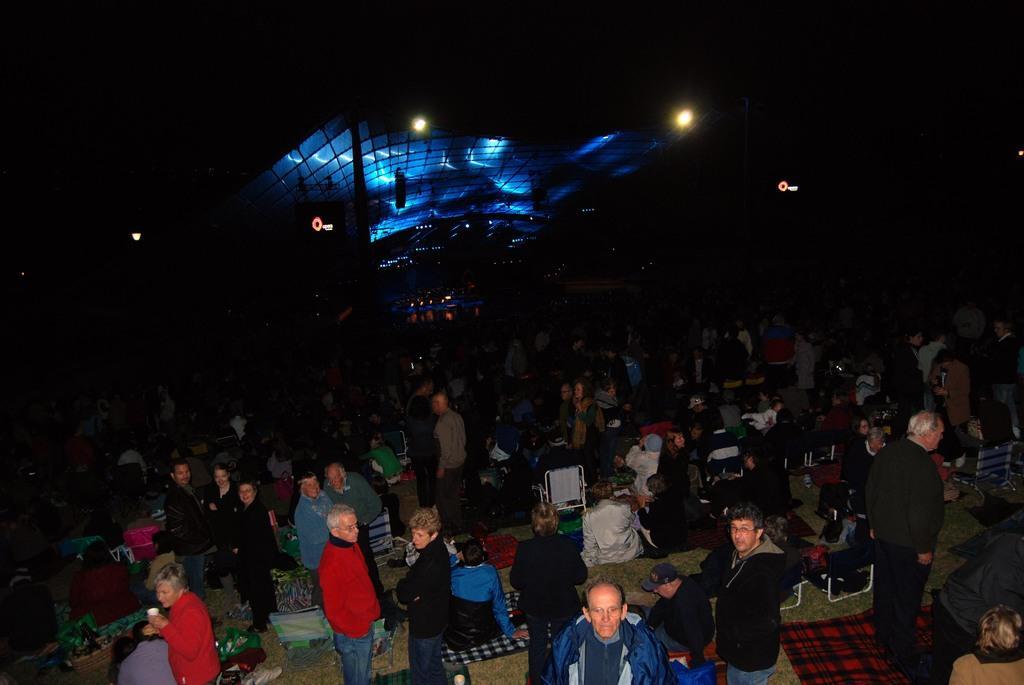Could you give a brief overview of what you see in this image? In this picture I can observe some people standing on the floor in the middle of the picture. There are men and women in this picture. In the background I can observe two lights and the surroundings are dark. 